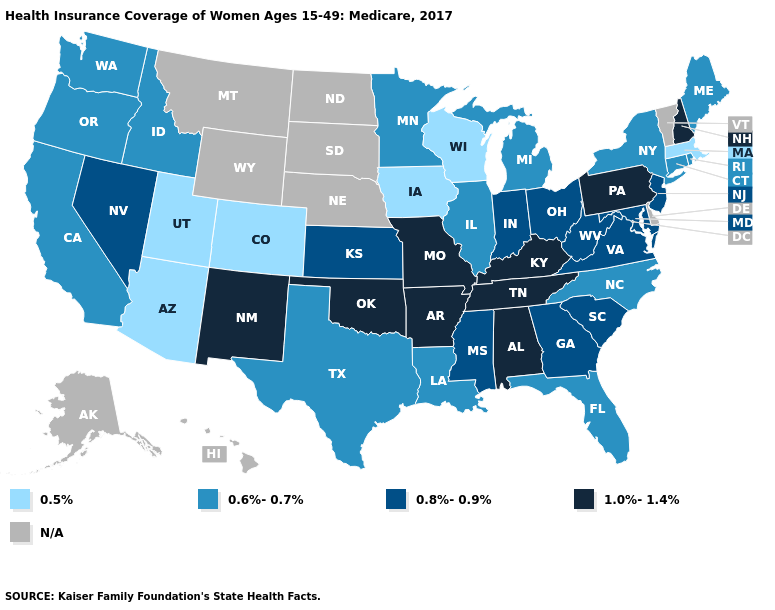Name the states that have a value in the range 0.5%?
Keep it brief. Arizona, Colorado, Iowa, Massachusetts, Utah, Wisconsin. Name the states that have a value in the range 1.0%-1.4%?
Give a very brief answer. Alabama, Arkansas, Kentucky, Missouri, New Hampshire, New Mexico, Oklahoma, Pennsylvania, Tennessee. Does Utah have the highest value in the West?
Keep it brief. No. Among the states that border North Carolina , which have the lowest value?
Be succinct. Georgia, South Carolina, Virginia. Among the states that border South Dakota , which have the lowest value?
Short answer required. Iowa. Does Louisiana have the lowest value in the South?
Concise answer only. Yes. Name the states that have a value in the range 0.6%-0.7%?
Keep it brief. California, Connecticut, Florida, Idaho, Illinois, Louisiana, Maine, Michigan, Minnesota, New York, North Carolina, Oregon, Rhode Island, Texas, Washington. Does Colorado have the lowest value in the West?
Give a very brief answer. Yes. What is the value of Nevada?
Answer briefly. 0.8%-0.9%. Which states hav the highest value in the Northeast?
Short answer required. New Hampshire, Pennsylvania. What is the value of Nebraska?
Write a very short answer. N/A. Name the states that have a value in the range 0.8%-0.9%?
Be succinct. Georgia, Indiana, Kansas, Maryland, Mississippi, Nevada, New Jersey, Ohio, South Carolina, Virginia, West Virginia. Name the states that have a value in the range N/A?
Write a very short answer. Alaska, Delaware, Hawaii, Montana, Nebraska, North Dakota, South Dakota, Vermont, Wyoming. Name the states that have a value in the range 0.6%-0.7%?
Answer briefly. California, Connecticut, Florida, Idaho, Illinois, Louisiana, Maine, Michigan, Minnesota, New York, North Carolina, Oregon, Rhode Island, Texas, Washington. Name the states that have a value in the range 0.8%-0.9%?
Short answer required. Georgia, Indiana, Kansas, Maryland, Mississippi, Nevada, New Jersey, Ohio, South Carolina, Virginia, West Virginia. 